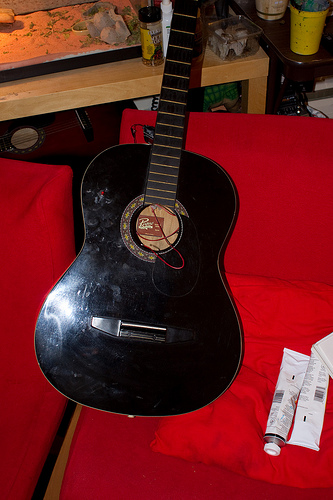<image>
Is there a guitar on the sofa? Yes. Looking at the image, I can see the guitar is positioned on top of the sofa, with the sofa providing support. Where is the guitar in relation to the cloth? Is it in front of the cloth? Yes. The guitar is positioned in front of the cloth, appearing closer to the camera viewpoint. 